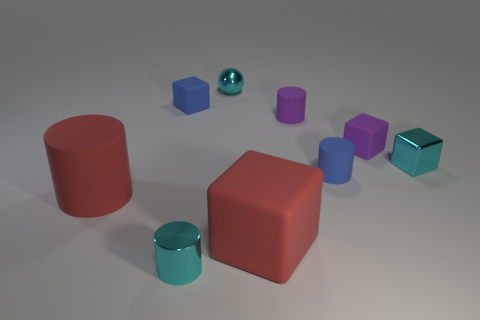Is the cube in front of the big red cylinder made of the same material as the large cylinder?
Offer a very short reply. Yes. What is the shape of the large object that is the same color as the large block?
Ensure brevity in your answer.  Cylinder. Do the big block in front of the red cylinder and the big object behind the large red matte cube have the same color?
Provide a succinct answer. Yes. How many tiny things are behind the cyan metallic cylinder and to the right of the tiny blue rubber cube?
Keep it short and to the point. 5. What is the purple cube made of?
Offer a very short reply. Rubber. What shape is the blue object that is the same size as the blue cube?
Your response must be concise. Cylinder. Is the material of the small blue thing that is behind the small purple rubber block the same as the small thing that is right of the purple rubber cube?
Offer a very short reply. No. How many small blue things are there?
Offer a terse response. 2. The blue rubber cylinder has what size?
Keep it short and to the point. Small. What number of red matte blocks have the same size as the cyan shiny ball?
Make the answer very short. 0. 